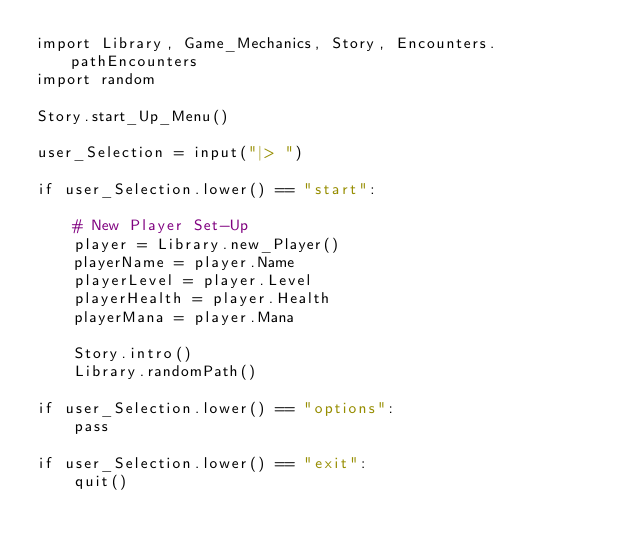<code> <loc_0><loc_0><loc_500><loc_500><_Python_>import Library, Game_Mechanics, Story, Encounters.pathEncounters
import random

Story.start_Up_Menu()

user_Selection = input("|> ")

if user_Selection.lower() == "start":

    # New Player Set-Up
    player = Library.new_Player()
    playerName = player.Name
    playerLevel = player.Level
    playerHealth = player.Health
    playerMana = player.Mana

    Story.intro()
    Library.randomPath()

if user_Selection.lower() == "options":
    pass

if user_Selection.lower() == "exit":
    quit()

</code> 